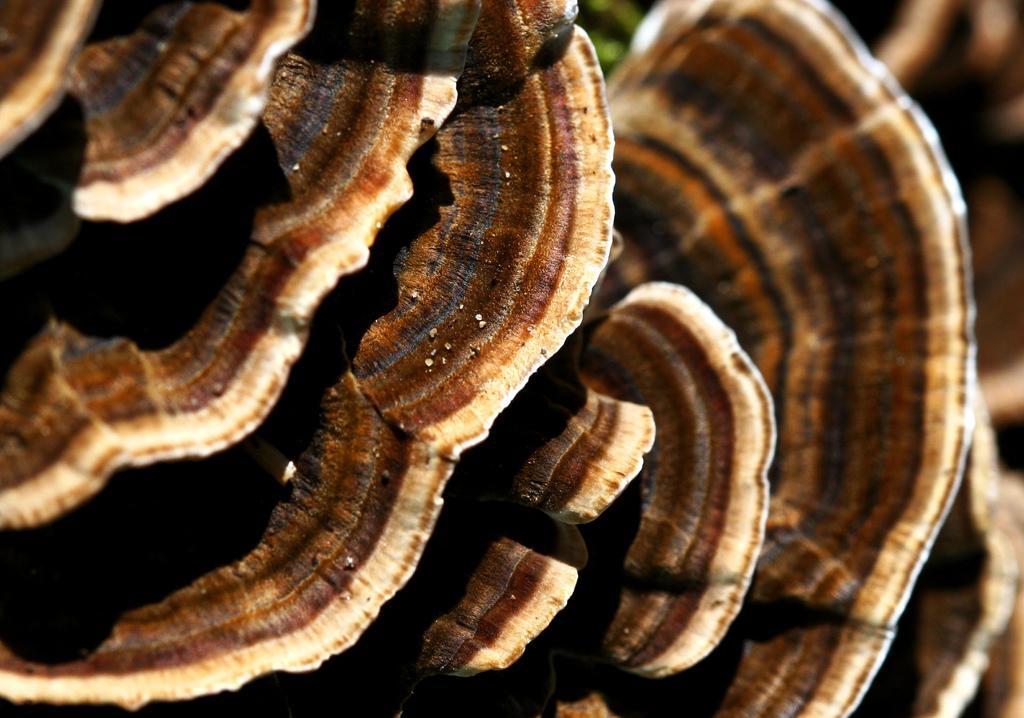In one or two sentences, can you explain what this image depicts? In this image I can see few objects they are in brown, black and cream color, and I can see black color background. 